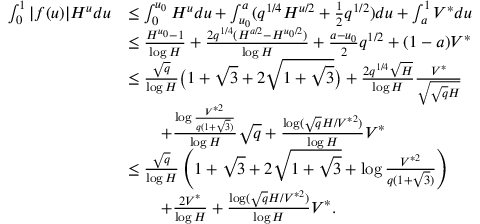<formula> <loc_0><loc_0><loc_500><loc_500>\begin{array} { r l } { \int _ { 0 } ^ { 1 } | f ( u ) | H ^ { u } d u } & { \leq \int _ { 0 } ^ { u _ { 0 } } H ^ { u } d u + \int _ { u _ { 0 } } ^ { a } ( q ^ { 1 / 4 } H ^ { u / 2 } + \frac { 1 } { 2 } q ^ { 1 / 2 } ) d u + \int _ { a } ^ { 1 } V ^ { * } d u } \\ & { \leq \frac { H ^ { u _ { 0 } } - 1 } { \log H } + \frac { 2 q ^ { 1 / 4 } ( H ^ { a / 2 } - H ^ { u _ { 0 } / 2 } ) } { \log H } + \frac { a - u _ { 0 } } { 2 } q ^ { 1 / 2 } + ( 1 - a ) V ^ { * } } \\ & { \leq \frac { \sqrt { q } } { \log H } \left ( 1 + \sqrt { 3 } + 2 \sqrt { 1 + \sqrt { 3 } } \right ) + \frac { 2 q ^ { 1 / 4 } \sqrt { H } } { \log H } \frac { V ^ { * } } { \sqrt { \sqrt { q } H } } } \\ & { \quad + \frac { \log \frac { V ^ { * 2 } } { q ( 1 + \sqrt { 3 } ) } } { \log H } \sqrt { q } + \frac { \log ( \sqrt { q } H / V ^ { * 2 } ) } { \log H } V ^ { * } } \\ & { \leq \frac { \sqrt { q } } { \log H } \left ( 1 + \sqrt { 3 } + 2 \sqrt { 1 + \sqrt { 3 } } + \log \frac { V ^ { * 2 } } { q ( 1 + \sqrt { 3 } ) } \right ) } \\ & { \quad + \frac { 2 V ^ { * } } { \log H } + \frac { \log ( \sqrt { q } H / V ^ { * 2 } ) } { \log H } V ^ { * } . } \end{array}</formula> 